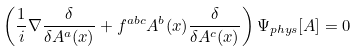<formula> <loc_0><loc_0><loc_500><loc_500>\left ( \frac { 1 } { i } \nabla \frac { \delta } { \delta A ^ { a } ( x ) } + f ^ { a b c } A ^ { b } ( x ) \frac { \delta } { \delta A ^ { c } ( x ) } \right ) \Psi _ { p h y s } [ A ] = 0</formula> 